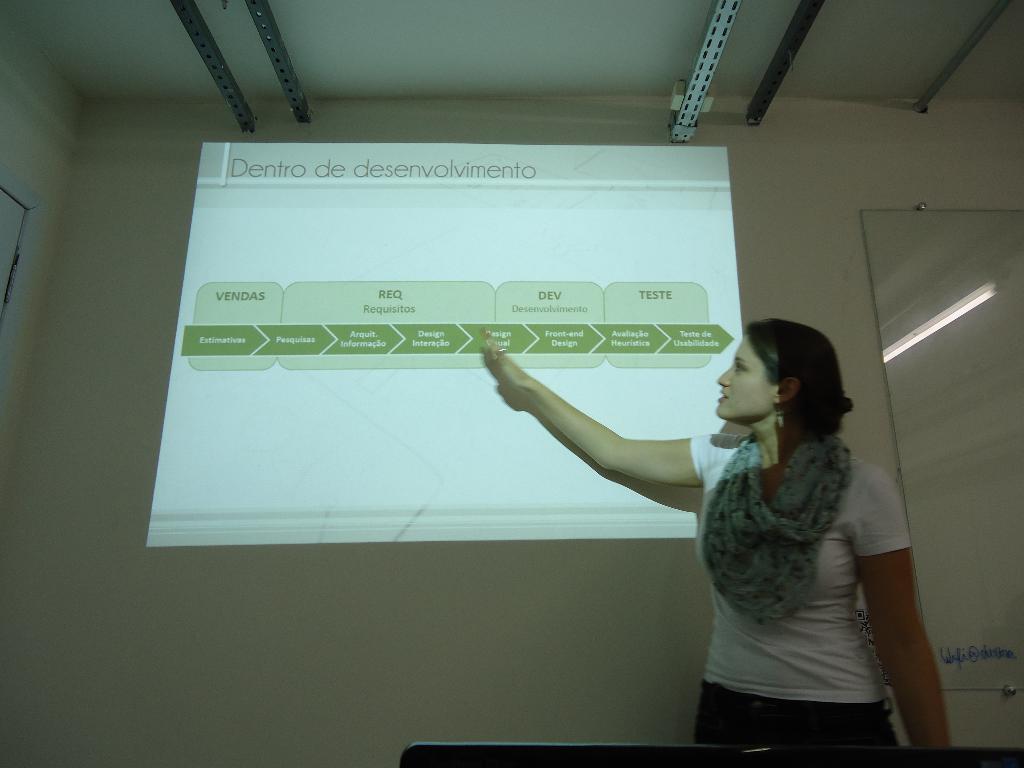What is the title of her presentation?
Offer a terse response. Dentro de desenvolvimento. 